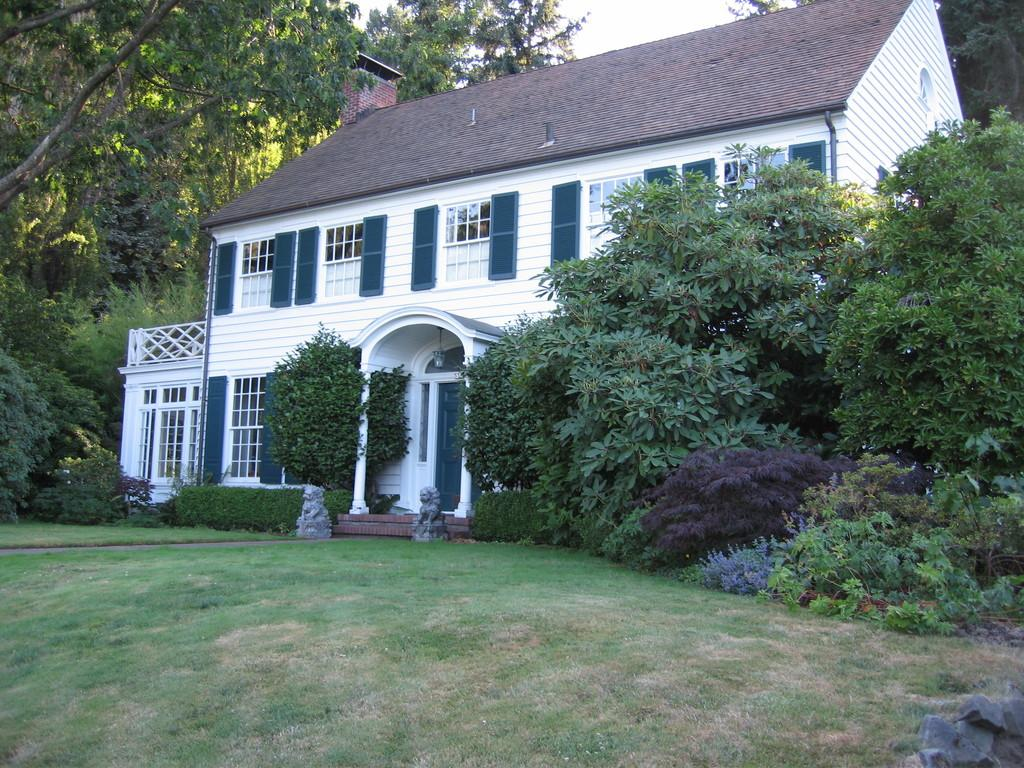What type of surface is on the ground in the image? There is grass on the ground in the image. What can be seen in the background of the image? There are trees, plants, and a white-colored building in the background. Can you describe the building in the background? The building has windows and a door. What is visible in the sky in the image? The sky is visible in the image. How does the feather help the building maintain its balance in the image? There is no feather present in the image, so it cannot help the building maintain its balance. 